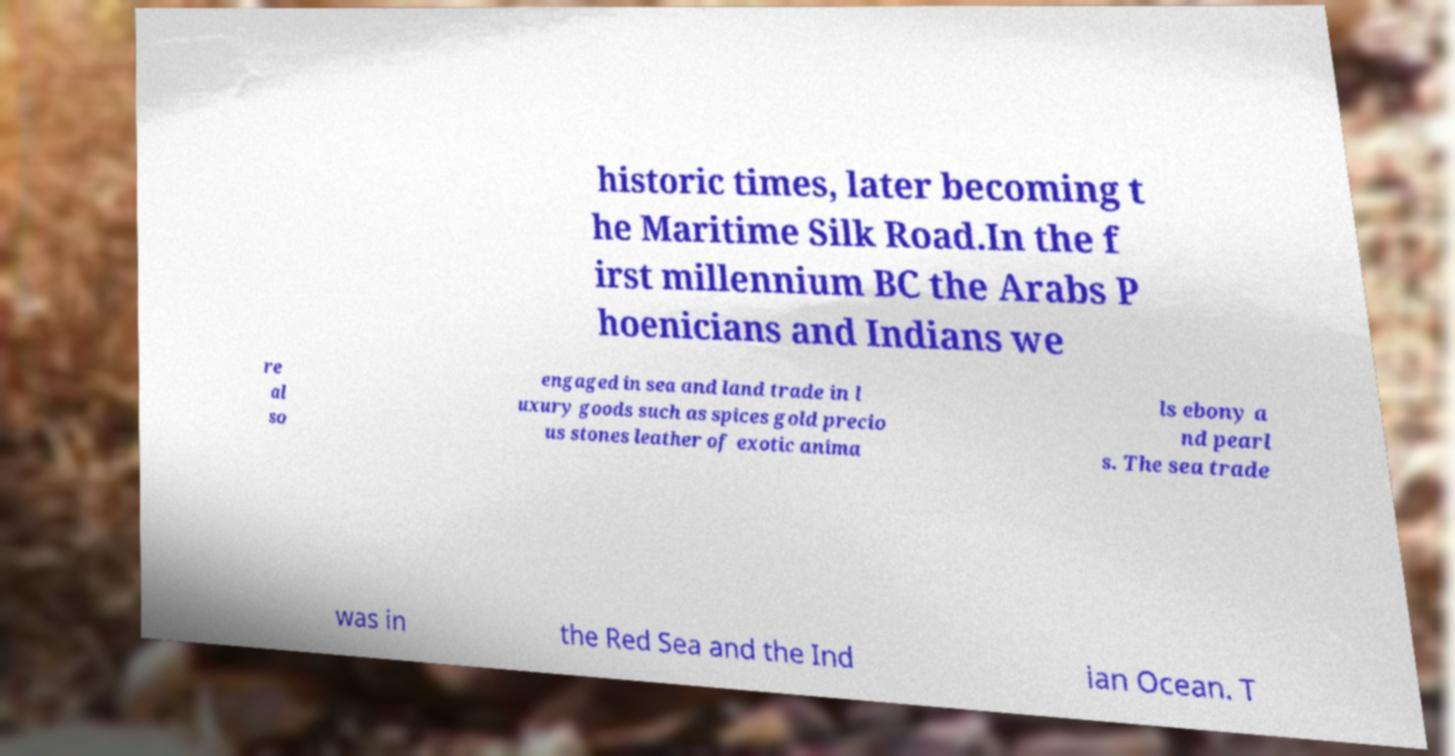Please read and relay the text visible in this image. What does it say? historic times, later becoming t he Maritime Silk Road.In the f irst millennium BC the Arabs P hoenicians and Indians we re al so engaged in sea and land trade in l uxury goods such as spices gold precio us stones leather of exotic anima ls ebony a nd pearl s. The sea trade was in the Red Sea and the Ind ian Ocean. T 